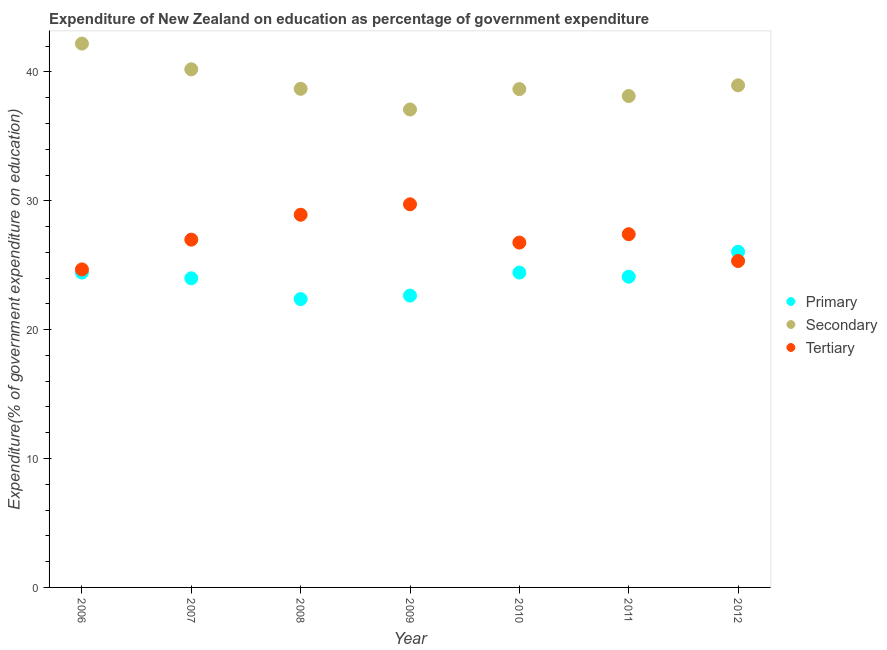What is the expenditure on secondary education in 2009?
Your answer should be very brief. 37.09. Across all years, what is the maximum expenditure on tertiary education?
Provide a short and direct response. 29.73. Across all years, what is the minimum expenditure on secondary education?
Your response must be concise. 37.09. In which year was the expenditure on secondary education minimum?
Your answer should be very brief. 2009. What is the total expenditure on tertiary education in the graph?
Your response must be concise. 189.8. What is the difference between the expenditure on secondary education in 2010 and that in 2011?
Offer a terse response. 0.54. What is the difference between the expenditure on tertiary education in 2011 and the expenditure on primary education in 2006?
Your answer should be very brief. 2.98. What is the average expenditure on secondary education per year?
Your answer should be very brief. 39.13. In the year 2012, what is the difference between the expenditure on tertiary education and expenditure on secondary education?
Keep it short and to the point. -13.63. What is the ratio of the expenditure on tertiary education in 2007 to that in 2010?
Make the answer very short. 1.01. Is the difference between the expenditure on secondary education in 2009 and 2010 greater than the difference between the expenditure on tertiary education in 2009 and 2010?
Make the answer very short. No. What is the difference between the highest and the second highest expenditure on secondary education?
Make the answer very short. 2. What is the difference between the highest and the lowest expenditure on secondary education?
Keep it short and to the point. 5.11. Is the sum of the expenditure on secondary education in 2007 and 2010 greater than the maximum expenditure on tertiary education across all years?
Provide a short and direct response. Yes. Does the expenditure on primary education monotonically increase over the years?
Offer a very short reply. No. Is the expenditure on primary education strictly greater than the expenditure on tertiary education over the years?
Offer a terse response. No. What is the difference between two consecutive major ticks on the Y-axis?
Your answer should be compact. 10. Does the graph contain any zero values?
Offer a terse response. No. Does the graph contain grids?
Provide a succinct answer. No. What is the title of the graph?
Keep it short and to the point. Expenditure of New Zealand on education as percentage of government expenditure. Does "Maunufacturing" appear as one of the legend labels in the graph?
Offer a very short reply. No. What is the label or title of the Y-axis?
Keep it short and to the point. Expenditure(% of government expenditure on education). What is the Expenditure(% of government expenditure on education) of Primary in 2006?
Your response must be concise. 24.43. What is the Expenditure(% of government expenditure on education) in Secondary in 2006?
Your response must be concise. 42.2. What is the Expenditure(% of government expenditure on education) in Tertiary in 2006?
Provide a short and direct response. 24.68. What is the Expenditure(% of government expenditure on education) in Primary in 2007?
Keep it short and to the point. 23.99. What is the Expenditure(% of government expenditure on education) of Secondary in 2007?
Make the answer very short. 40.2. What is the Expenditure(% of government expenditure on education) of Tertiary in 2007?
Give a very brief answer. 26.99. What is the Expenditure(% of government expenditure on education) in Primary in 2008?
Give a very brief answer. 22.37. What is the Expenditure(% of government expenditure on education) of Secondary in 2008?
Offer a very short reply. 38.69. What is the Expenditure(% of government expenditure on education) in Tertiary in 2008?
Make the answer very short. 28.92. What is the Expenditure(% of government expenditure on education) of Primary in 2009?
Your response must be concise. 22.65. What is the Expenditure(% of government expenditure on education) in Secondary in 2009?
Your response must be concise. 37.09. What is the Expenditure(% of government expenditure on education) of Tertiary in 2009?
Give a very brief answer. 29.73. What is the Expenditure(% of government expenditure on education) in Primary in 2010?
Provide a succinct answer. 24.43. What is the Expenditure(% of government expenditure on education) in Secondary in 2010?
Your response must be concise. 38.67. What is the Expenditure(% of government expenditure on education) in Tertiary in 2010?
Make the answer very short. 26.76. What is the Expenditure(% of government expenditure on education) in Primary in 2011?
Your response must be concise. 24.11. What is the Expenditure(% of government expenditure on education) in Secondary in 2011?
Make the answer very short. 38.13. What is the Expenditure(% of government expenditure on education) of Tertiary in 2011?
Offer a terse response. 27.41. What is the Expenditure(% of government expenditure on education) in Primary in 2012?
Provide a succinct answer. 26.05. What is the Expenditure(% of government expenditure on education) of Secondary in 2012?
Give a very brief answer. 38.96. What is the Expenditure(% of government expenditure on education) of Tertiary in 2012?
Provide a short and direct response. 25.33. Across all years, what is the maximum Expenditure(% of government expenditure on education) of Primary?
Make the answer very short. 26.05. Across all years, what is the maximum Expenditure(% of government expenditure on education) of Secondary?
Offer a terse response. 42.2. Across all years, what is the maximum Expenditure(% of government expenditure on education) in Tertiary?
Your answer should be very brief. 29.73. Across all years, what is the minimum Expenditure(% of government expenditure on education) of Primary?
Offer a very short reply. 22.37. Across all years, what is the minimum Expenditure(% of government expenditure on education) of Secondary?
Give a very brief answer. 37.09. Across all years, what is the minimum Expenditure(% of government expenditure on education) in Tertiary?
Ensure brevity in your answer.  24.68. What is the total Expenditure(% of government expenditure on education) in Primary in the graph?
Make the answer very short. 168.02. What is the total Expenditure(% of government expenditure on education) in Secondary in the graph?
Give a very brief answer. 273.93. What is the total Expenditure(% of government expenditure on education) in Tertiary in the graph?
Your answer should be compact. 189.8. What is the difference between the Expenditure(% of government expenditure on education) in Primary in 2006 and that in 2007?
Offer a terse response. 0.44. What is the difference between the Expenditure(% of government expenditure on education) of Secondary in 2006 and that in 2007?
Offer a very short reply. 2. What is the difference between the Expenditure(% of government expenditure on education) of Tertiary in 2006 and that in 2007?
Ensure brevity in your answer.  -2.31. What is the difference between the Expenditure(% of government expenditure on education) of Primary in 2006 and that in 2008?
Your response must be concise. 2.06. What is the difference between the Expenditure(% of government expenditure on education) of Secondary in 2006 and that in 2008?
Provide a succinct answer. 3.51. What is the difference between the Expenditure(% of government expenditure on education) in Tertiary in 2006 and that in 2008?
Ensure brevity in your answer.  -4.24. What is the difference between the Expenditure(% of government expenditure on education) in Primary in 2006 and that in 2009?
Make the answer very short. 1.78. What is the difference between the Expenditure(% of government expenditure on education) of Secondary in 2006 and that in 2009?
Your response must be concise. 5.11. What is the difference between the Expenditure(% of government expenditure on education) of Tertiary in 2006 and that in 2009?
Your answer should be compact. -5.05. What is the difference between the Expenditure(% of government expenditure on education) of Primary in 2006 and that in 2010?
Make the answer very short. -0. What is the difference between the Expenditure(% of government expenditure on education) in Secondary in 2006 and that in 2010?
Keep it short and to the point. 3.53. What is the difference between the Expenditure(% of government expenditure on education) in Tertiary in 2006 and that in 2010?
Provide a short and direct response. -2.08. What is the difference between the Expenditure(% of government expenditure on education) in Primary in 2006 and that in 2011?
Your answer should be very brief. 0.32. What is the difference between the Expenditure(% of government expenditure on education) of Secondary in 2006 and that in 2011?
Ensure brevity in your answer.  4.07. What is the difference between the Expenditure(% of government expenditure on education) of Tertiary in 2006 and that in 2011?
Ensure brevity in your answer.  -2.73. What is the difference between the Expenditure(% of government expenditure on education) in Primary in 2006 and that in 2012?
Your answer should be very brief. -1.62. What is the difference between the Expenditure(% of government expenditure on education) of Secondary in 2006 and that in 2012?
Ensure brevity in your answer.  3.24. What is the difference between the Expenditure(% of government expenditure on education) of Tertiary in 2006 and that in 2012?
Offer a terse response. -0.65. What is the difference between the Expenditure(% of government expenditure on education) in Primary in 2007 and that in 2008?
Your answer should be compact. 1.61. What is the difference between the Expenditure(% of government expenditure on education) of Secondary in 2007 and that in 2008?
Offer a terse response. 1.51. What is the difference between the Expenditure(% of government expenditure on education) of Tertiary in 2007 and that in 2008?
Your response must be concise. -1.93. What is the difference between the Expenditure(% of government expenditure on education) of Primary in 2007 and that in 2009?
Offer a terse response. 1.34. What is the difference between the Expenditure(% of government expenditure on education) of Secondary in 2007 and that in 2009?
Give a very brief answer. 3.12. What is the difference between the Expenditure(% of government expenditure on education) in Tertiary in 2007 and that in 2009?
Your response must be concise. -2.74. What is the difference between the Expenditure(% of government expenditure on education) of Primary in 2007 and that in 2010?
Keep it short and to the point. -0.44. What is the difference between the Expenditure(% of government expenditure on education) of Secondary in 2007 and that in 2010?
Provide a short and direct response. 1.53. What is the difference between the Expenditure(% of government expenditure on education) of Tertiary in 2007 and that in 2010?
Make the answer very short. 0.23. What is the difference between the Expenditure(% of government expenditure on education) in Primary in 2007 and that in 2011?
Your response must be concise. -0.12. What is the difference between the Expenditure(% of government expenditure on education) of Secondary in 2007 and that in 2011?
Your answer should be very brief. 2.07. What is the difference between the Expenditure(% of government expenditure on education) in Tertiary in 2007 and that in 2011?
Give a very brief answer. -0.42. What is the difference between the Expenditure(% of government expenditure on education) of Primary in 2007 and that in 2012?
Keep it short and to the point. -2.06. What is the difference between the Expenditure(% of government expenditure on education) of Secondary in 2007 and that in 2012?
Keep it short and to the point. 1.24. What is the difference between the Expenditure(% of government expenditure on education) of Tertiary in 2007 and that in 2012?
Offer a very short reply. 1.66. What is the difference between the Expenditure(% of government expenditure on education) in Primary in 2008 and that in 2009?
Keep it short and to the point. -0.27. What is the difference between the Expenditure(% of government expenditure on education) in Secondary in 2008 and that in 2009?
Ensure brevity in your answer.  1.6. What is the difference between the Expenditure(% of government expenditure on education) in Tertiary in 2008 and that in 2009?
Your answer should be very brief. -0.81. What is the difference between the Expenditure(% of government expenditure on education) in Primary in 2008 and that in 2010?
Make the answer very short. -2.06. What is the difference between the Expenditure(% of government expenditure on education) in Secondary in 2008 and that in 2010?
Your answer should be compact. 0.02. What is the difference between the Expenditure(% of government expenditure on education) of Tertiary in 2008 and that in 2010?
Offer a terse response. 2.16. What is the difference between the Expenditure(% of government expenditure on education) in Primary in 2008 and that in 2011?
Ensure brevity in your answer.  -1.74. What is the difference between the Expenditure(% of government expenditure on education) in Secondary in 2008 and that in 2011?
Provide a short and direct response. 0.56. What is the difference between the Expenditure(% of government expenditure on education) in Tertiary in 2008 and that in 2011?
Your answer should be compact. 1.51. What is the difference between the Expenditure(% of government expenditure on education) of Primary in 2008 and that in 2012?
Give a very brief answer. -3.68. What is the difference between the Expenditure(% of government expenditure on education) of Secondary in 2008 and that in 2012?
Keep it short and to the point. -0.27. What is the difference between the Expenditure(% of government expenditure on education) in Tertiary in 2008 and that in 2012?
Provide a short and direct response. 3.59. What is the difference between the Expenditure(% of government expenditure on education) in Primary in 2009 and that in 2010?
Offer a very short reply. -1.78. What is the difference between the Expenditure(% of government expenditure on education) of Secondary in 2009 and that in 2010?
Offer a very short reply. -1.58. What is the difference between the Expenditure(% of government expenditure on education) in Tertiary in 2009 and that in 2010?
Keep it short and to the point. 2.97. What is the difference between the Expenditure(% of government expenditure on education) in Primary in 2009 and that in 2011?
Your answer should be very brief. -1.46. What is the difference between the Expenditure(% of government expenditure on education) of Secondary in 2009 and that in 2011?
Offer a terse response. -1.04. What is the difference between the Expenditure(% of government expenditure on education) in Tertiary in 2009 and that in 2011?
Your response must be concise. 2.32. What is the difference between the Expenditure(% of government expenditure on education) in Primary in 2009 and that in 2012?
Offer a terse response. -3.4. What is the difference between the Expenditure(% of government expenditure on education) of Secondary in 2009 and that in 2012?
Offer a terse response. -1.87. What is the difference between the Expenditure(% of government expenditure on education) in Tertiary in 2009 and that in 2012?
Offer a terse response. 4.4. What is the difference between the Expenditure(% of government expenditure on education) in Primary in 2010 and that in 2011?
Give a very brief answer. 0.32. What is the difference between the Expenditure(% of government expenditure on education) in Secondary in 2010 and that in 2011?
Ensure brevity in your answer.  0.54. What is the difference between the Expenditure(% of government expenditure on education) in Tertiary in 2010 and that in 2011?
Keep it short and to the point. -0.65. What is the difference between the Expenditure(% of government expenditure on education) of Primary in 2010 and that in 2012?
Give a very brief answer. -1.62. What is the difference between the Expenditure(% of government expenditure on education) of Secondary in 2010 and that in 2012?
Your answer should be compact. -0.29. What is the difference between the Expenditure(% of government expenditure on education) in Tertiary in 2010 and that in 2012?
Make the answer very short. 1.43. What is the difference between the Expenditure(% of government expenditure on education) in Primary in 2011 and that in 2012?
Your response must be concise. -1.94. What is the difference between the Expenditure(% of government expenditure on education) in Secondary in 2011 and that in 2012?
Provide a succinct answer. -0.83. What is the difference between the Expenditure(% of government expenditure on education) of Tertiary in 2011 and that in 2012?
Offer a terse response. 2.08. What is the difference between the Expenditure(% of government expenditure on education) of Primary in 2006 and the Expenditure(% of government expenditure on education) of Secondary in 2007?
Ensure brevity in your answer.  -15.77. What is the difference between the Expenditure(% of government expenditure on education) of Primary in 2006 and the Expenditure(% of government expenditure on education) of Tertiary in 2007?
Ensure brevity in your answer.  -2.56. What is the difference between the Expenditure(% of government expenditure on education) in Secondary in 2006 and the Expenditure(% of government expenditure on education) in Tertiary in 2007?
Make the answer very short. 15.21. What is the difference between the Expenditure(% of government expenditure on education) in Primary in 2006 and the Expenditure(% of government expenditure on education) in Secondary in 2008?
Your answer should be compact. -14.26. What is the difference between the Expenditure(% of government expenditure on education) of Primary in 2006 and the Expenditure(% of government expenditure on education) of Tertiary in 2008?
Keep it short and to the point. -4.49. What is the difference between the Expenditure(% of government expenditure on education) of Secondary in 2006 and the Expenditure(% of government expenditure on education) of Tertiary in 2008?
Your response must be concise. 13.28. What is the difference between the Expenditure(% of government expenditure on education) in Primary in 2006 and the Expenditure(% of government expenditure on education) in Secondary in 2009?
Give a very brief answer. -12.66. What is the difference between the Expenditure(% of government expenditure on education) in Primary in 2006 and the Expenditure(% of government expenditure on education) in Tertiary in 2009?
Offer a terse response. -5.3. What is the difference between the Expenditure(% of government expenditure on education) of Secondary in 2006 and the Expenditure(% of government expenditure on education) of Tertiary in 2009?
Provide a succinct answer. 12.47. What is the difference between the Expenditure(% of government expenditure on education) of Primary in 2006 and the Expenditure(% of government expenditure on education) of Secondary in 2010?
Give a very brief answer. -14.24. What is the difference between the Expenditure(% of government expenditure on education) of Primary in 2006 and the Expenditure(% of government expenditure on education) of Tertiary in 2010?
Offer a very short reply. -2.33. What is the difference between the Expenditure(% of government expenditure on education) in Secondary in 2006 and the Expenditure(% of government expenditure on education) in Tertiary in 2010?
Your answer should be compact. 15.44. What is the difference between the Expenditure(% of government expenditure on education) of Primary in 2006 and the Expenditure(% of government expenditure on education) of Secondary in 2011?
Your answer should be compact. -13.7. What is the difference between the Expenditure(% of government expenditure on education) of Primary in 2006 and the Expenditure(% of government expenditure on education) of Tertiary in 2011?
Ensure brevity in your answer.  -2.98. What is the difference between the Expenditure(% of government expenditure on education) of Secondary in 2006 and the Expenditure(% of government expenditure on education) of Tertiary in 2011?
Your answer should be very brief. 14.79. What is the difference between the Expenditure(% of government expenditure on education) in Primary in 2006 and the Expenditure(% of government expenditure on education) in Secondary in 2012?
Offer a terse response. -14.53. What is the difference between the Expenditure(% of government expenditure on education) of Primary in 2006 and the Expenditure(% of government expenditure on education) of Tertiary in 2012?
Your response must be concise. -0.9. What is the difference between the Expenditure(% of government expenditure on education) in Secondary in 2006 and the Expenditure(% of government expenditure on education) in Tertiary in 2012?
Offer a very short reply. 16.87. What is the difference between the Expenditure(% of government expenditure on education) of Primary in 2007 and the Expenditure(% of government expenditure on education) of Secondary in 2008?
Your answer should be compact. -14.7. What is the difference between the Expenditure(% of government expenditure on education) of Primary in 2007 and the Expenditure(% of government expenditure on education) of Tertiary in 2008?
Keep it short and to the point. -4.93. What is the difference between the Expenditure(% of government expenditure on education) of Secondary in 2007 and the Expenditure(% of government expenditure on education) of Tertiary in 2008?
Offer a very short reply. 11.28. What is the difference between the Expenditure(% of government expenditure on education) of Primary in 2007 and the Expenditure(% of government expenditure on education) of Secondary in 2009?
Offer a very short reply. -13.1. What is the difference between the Expenditure(% of government expenditure on education) in Primary in 2007 and the Expenditure(% of government expenditure on education) in Tertiary in 2009?
Make the answer very short. -5.74. What is the difference between the Expenditure(% of government expenditure on education) of Secondary in 2007 and the Expenditure(% of government expenditure on education) of Tertiary in 2009?
Keep it short and to the point. 10.47. What is the difference between the Expenditure(% of government expenditure on education) in Primary in 2007 and the Expenditure(% of government expenditure on education) in Secondary in 2010?
Provide a short and direct response. -14.68. What is the difference between the Expenditure(% of government expenditure on education) of Primary in 2007 and the Expenditure(% of government expenditure on education) of Tertiary in 2010?
Your answer should be compact. -2.77. What is the difference between the Expenditure(% of government expenditure on education) of Secondary in 2007 and the Expenditure(% of government expenditure on education) of Tertiary in 2010?
Offer a terse response. 13.44. What is the difference between the Expenditure(% of government expenditure on education) of Primary in 2007 and the Expenditure(% of government expenditure on education) of Secondary in 2011?
Offer a very short reply. -14.14. What is the difference between the Expenditure(% of government expenditure on education) of Primary in 2007 and the Expenditure(% of government expenditure on education) of Tertiary in 2011?
Keep it short and to the point. -3.42. What is the difference between the Expenditure(% of government expenditure on education) of Secondary in 2007 and the Expenditure(% of government expenditure on education) of Tertiary in 2011?
Provide a short and direct response. 12.79. What is the difference between the Expenditure(% of government expenditure on education) of Primary in 2007 and the Expenditure(% of government expenditure on education) of Secondary in 2012?
Keep it short and to the point. -14.97. What is the difference between the Expenditure(% of government expenditure on education) of Primary in 2007 and the Expenditure(% of government expenditure on education) of Tertiary in 2012?
Provide a short and direct response. -1.34. What is the difference between the Expenditure(% of government expenditure on education) in Secondary in 2007 and the Expenditure(% of government expenditure on education) in Tertiary in 2012?
Your response must be concise. 14.87. What is the difference between the Expenditure(% of government expenditure on education) of Primary in 2008 and the Expenditure(% of government expenditure on education) of Secondary in 2009?
Keep it short and to the point. -14.71. What is the difference between the Expenditure(% of government expenditure on education) of Primary in 2008 and the Expenditure(% of government expenditure on education) of Tertiary in 2009?
Your answer should be very brief. -7.35. What is the difference between the Expenditure(% of government expenditure on education) of Secondary in 2008 and the Expenditure(% of government expenditure on education) of Tertiary in 2009?
Your answer should be very brief. 8.96. What is the difference between the Expenditure(% of government expenditure on education) in Primary in 2008 and the Expenditure(% of government expenditure on education) in Secondary in 2010?
Offer a terse response. -16.3. What is the difference between the Expenditure(% of government expenditure on education) of Primary in 2008 and the Expenditure(% of government expenditure on education) of Tertiary in 2010?
Make the answer very short. -4.38. What is the difference between the Expenditure(% of government expenditure on education) in Secondary in 2008 and the Expenditure(% of government expenditure on education) in Tertiary in 2010?
Provide a succinct answer. 11.93. What is the difference between the Expenditure(% of government expenditure on education) of Primary in 2008 and the Expenditure(% of government expenditure on education) of Secondary in 2011?
Provide a short and direct response. -15.76. What is the difference between the Expenditure(% of government expenditure on education) of Primary in 2008 and the Expenditure(% of government expenditure on education) of Tertiary in 2011?
Your answer should be very brief. -5.04. What is the difference between the Expenditure(% of government expenditure on education) in Secondary in 2008 and the Expenditure(% of government expenditure on education) in Tertiary in 2011?
Ensure brevity in your answer.  11.28. What is the difference between the Expenditure(% of government expenditure on education) in Primary in 2008 and the Expenditure(% of government expenditure on education) in Secondary in 2012?
Your answer should be compact. -16.59. What is the difference between the Expenditure(% of government expenditure on education) of Primary in 2008 and the Expenditure(% of government expenditure on education) of Tertiary in 2012?
Make the answer very short. -2.96. What is the difference between the Expenditure(% of government expenditure on education) in Secondary in 2008 and the Expenditure(% of government expenditure on education) in Tertiary in 2012?
Offer a terse response. 13.36. What is the difference between the Expenditure(% of government expenditure on education) in Primary in 2009 and the Expenditure(% of government expenditure on education) in Secondary in 2010?
Your answer should be very brief. -16.02. What is the difference between the Expenditure(% of government expenditure on education) of Primary in 2009 and the Expenditure(% of government expenditure on education) of Tertiary in 2010?
Provide a succinct answer. -4.11. What is the difference between the Expenditure(% of government expenditure on education) of Secondary in 2009 and the Expenditure(% of government expenditure on education) of Tertiary in 2010?
Offer a very short reply. 10.33. What is the difference between the Expenditure(% of government expenditure on education) in Primary in 2009 and the Expenditure(% of government expenditure on education) in Secondary in 2011?
Your answer should be very brief. -15.48. What is the difference between the Expenditure(% of government expenditure on education) in Primary in 2009 and the Expenditure(% of government expenditure on education) in Tertiary in 2011?
Make the answer very short. -4.76. What is the difference between the Expenditure(% of government expenditure on education) in Secondary in 2009 and the Expenditure(% of government expenditure on education) in Tertiary in 2011?
Give a very brief answer. 9.68. What is the difference between the Expenditure(% of government expenditure on education) in Primary in 2009 and the Expenditure(% of government expenditure on education) in Secondary in 2012?
Ensure brevity in your answer.  -16.31. What is the difference between the Expenditure(% of government expenditure on education) in Primary in 2009 and the Expenditure(% of government expenditure on education) in Tertiary in 2012?
Provide a succinct answer. -2.68. What is the difference between the Expenditure(% of government expenditure on education) in Secondary in 2009 and the Expenditure(% of government expenditure on education) in Tertiary in 2012?
Your answer should be very brief. 11.76. What is the difference between the Expenditure(% of government expenditure on education) in Primary in 2010 and the Expenditure(% of government expenditure on education) in Secondary in 2011?
Offer a terse response. -13.7. What is the difference between the Expenditure(% of government expenditure on education) of Primary in 2010 and the Expenditure(% of government expenditure on education) of Tertiary in 2011?
Make the answer very short. -2.98. What is the difference between the Expenditure(% of government expenditure on education) of Secondary in 2010 and the Expenditure(% of government expenditure on education) of Tertiary in 2011?
Provide a short and direct response. 11.26. What is the difference between the Expenditure(% of government expenditure on education) in Primary in 2010 and the Expenditure(% of government expenditure on education) in Secondary in 2012?
Your response must be concise. -14.53. What is the difference between the Expenditure(% of government expenditure on education) in Primary in 2010 and the Expenditure(% of government expenditure on education) in Tertiary in 2012?
Offer a very short reply. -0.9. What is the difference between the Expenditure(% of government expenditure on education) of Secondary in 2010 and the Expenditure(% of government expenditure on education) of Tertiary in 2012?
Provide a short and direct response. 13.34. What is the difference between the Expenditure(% of government expenditure on education) of Primary in 2011 and the Expenditure(% of government expenditure on education) of Secondary in 2012?
Offer a very short reply. -14.85. What is the difference between the Expenditure(% of government expenditure on education) of Primary in 2011 and the Expenditure(% of government expenditure on education) of Tertiary in 2012?
Keep it short and to the point. -1.22. What is the difference between the Expenditure(% of government expenditure on education) in Secondary in 2011 and the Expenditure(% of government expenditure on education) in Tertiary in 2012?
Keep it short and to the point. 12.8. What is the average Expenditure(% of government expenditure on education) of Primary per year?
Offer a terse response. 24. What is the average Expenditure(% of government expenditure on education) in Secondary per year?
Your answer should be compact. 39.13. What is the average Expenditure(% of government expenditure on education) of Tertiary per year?
Ensure brevity in your answer.  27.11. In the year 2006, what is the difference between the Expenditure(% of government expenditure on education) in Primary and Expenditure(% of government expenditure on education) in Secondary?
Ensure brevity in your answer.  -17.77. In the year 2006, what is the difference between the Expenditure(% of government expenditure on education) in Primary and Expenditure(% of government expenditure on education) in Tertiary?
Offer a terse response. -0.25. In the year 2006, what is the difference between the Expenditure(% of government expenditure on education) in Secondary and Expenditure(% of government expenditure on education) in Tertiary?
Offer a very short reply. 17.52. In the year 2007, what is the difference between the Expenditure(% of government expenditure on education) of Primary and Expenditure(% of government expenditure on education) of Secondary?
Make the answer very short. -16.22. In the year 2007, what is the difference between the Expenditure(% of government expenditure on education) in Primary and Expenditure(% of government expenditure on education) in Tertiary?
Your answer should be compact. -3. In the year 2007, what is the difference between the Expenditure(% of government expenditure on education) in Secondary and Expenditure(% of government expenditure on education) in Tertiary?
Your answer should be compact. 13.22. In the year 2008, what is the difference between the Expenditure(% of government expenditure on education) of Primary and Expenditure(% of government expenditure on education) of Secondary?
Your answer should be compact. -16.32. In the year 2008, what is the difference between the Expenditure(% of government expenditure on education) in Primary and Expenditure(% of government expenditure on education) in Tertiary?
Your answer should be compact. -6.54. In the year 2008, what is the difference between the Expenditure(% of government expenditure on education) of Secondary and Expenditure(% of government expenditure on education) of Tertiary?
Make the answer very short. 9.77. In the year 2009, what is the difference between the Expenditure(% of government expenditure on education) of Primary and Expenditure(% of government expenditure on education) of Secondary?
Your answer should be very brief. -14.44. In the year 2009, what is the difference between the Expenditure(% of government expenditure on education) of Primary and Expenditure(% of government expenditure on education) of Tertiary?
Your answer should be compact. -7.08. In the year 2009, what is the difference between the Expenditure(% of government expenditure on education) in Secondary and Expenditure(% of government expenditure on education) in Tertiary?
Your response must be concise. 7.36. In the year 2010, what is the difference between the Expenditure(% of government expenditure on education) of Primary and Expenditure(% of government expenditure on education) of Secondary?
Offer a very short reply. -14.24. In the year 2010, what is the difference between the Expenditure(% of government expenditure on education) in Primary and Expenditure(% of government expenditure on education) in Tertiary?
Give a very brief answer. -2.33. In the year 2010, what is the difference between the Expenditure(% of government expenditure on education) of Secondary and Expenditure(% of government expenditure on education) of Tertiary?
Offer a very short reply. 11.91. In the year 2011, what is the difference between the Expenditure(% of government expenditure on education) of Primary and Expenditure(% of government expenditure on education) of Secondary?
Provide a short and direct response. -14.02. In the year 2011, what is the difference between the Expenditure(% of government expenditure on education) in Primary and Expenditure(% of government expenditure on education) in Tertiary?
Keep it short and to the point. -3.3. In the year 2011, what is the difference between the Expenditure(% of government expenditure on education) of Secondary and Expenditure(% of government expenditure on education) of Tertiary?
Give a very brief answer. 10.72. In the year 2012, what is the difference between the Expenditure(% of government expenditure on education) in Primary and Expenditure(% of government expenditure on education) in Secondary?
Provide a succinct answer. -12.91. In the year 2012, what is the difference between the Expenditure(% of government expenditure on education) in Primary and Expenditure(% of government expenditure on education) in Tertiary?
Keep it short and to the point. 0.72. In the year 2012, what is the difference between the Expenditure(% of government expenditure on education) of Secondary and Expenditure(% of government expenditure on education) of Tertiary?
Provide a succinct answer. 13.63. What is the ratio of the Expenditure(% of government expenditure on education) of Primary in 2006 to that in 2007?
Provide a succinct answer. 1.02. What is the ratio of the Expenditure(% of government expenditure on education) in Secondary in 2006 to that in 2007?
Provide a short and direct response. 1.05. What is the ratio of the Expenditure(% of government expenditure on education) of Tertiary in 2006 to that in 2007?
Your answer should be very brief. 0.91. What is the ratio of the Expenditure(% of government expenditure on education) of Primary in 2006 to that in 2008?
Your answer should be compact. 1.09. What is the ratio of the Expenditure(% of government expenditure on education) in Secondary in 2006 to that in 2008?
Your answer should be very brief. 1.09. What is the ratio of the Expenditure(% of government expenditure on education) of Tertiary in 2006 to that in 2008?
Your answer should be compact. 0.85. What is the ratio of the Expenditure(% of government expenditure on education) of Primary in 2006 to that in 2009?
Your answer should be very brief. 1.08. What is the ratio of the Expenditure(% of government expenditure on education) in Secondary in 2006 to that in 2009?
Offer a terse response. 1.14. What is the ratio of the Expenditure(% of government expenditure on education) of Tertiary in 2006 to that in 2009?
Offer a very short reply. 0.83. What is the ratio of the Expenditure(% of government expenditure on education) of Secondary in 2006 to that in 2010?
Provide a short and direct response. 1.09. What is the ratio of the Expenditure(% of government expenditure on education) of Tertiary in 2006 to that in 2010?
Keep it short and to the point. 0.92. What is the ratio of the Expenditure(% of government expenditure on education) in Primary in 2006 to that in 2011?
Keep it short and to the point. 1.01. What is the ratio of the Expenditure(% of government expenditure on education) in Secondary in 2006 to that in 2011?
Make the answer very short. 1.11. What is the ratio of the Expenditure(% of government expenditure on education) in Tertiary in 2006 to that in 2011?
Offer a very short reply. 0.9. What is the ratio of the Expenditure(% of government expenditure on education) of Primary in 2006 to that in 2012?
Ensure brevity in your answer.  0.94. What is the ratio of the Expenditure(% of government expenditure on education) of Secondary in 2006 to that in 2012?
Offer a terse response. 1.08. What is the ratio of the Expenditure(% of government expenditure on education) in Tertiary in 2006 to that in 2012?
Make the answer very short. 0.97. What is the ratio of the Expenditure(% of government expenditure on education) in Primary in 2007 to that in 2008?
Your answer should be compact. 1.07. What is the ratio of the Expenditure(% of government expenditure on education) in Secondary in 2007 to that in 2008?
Make the answer very short. 1.04. What is the ratio of the Expenditure(% of government expenditure on education) in Tertiary in 2007 to that in 2008?
Offer a terse response. 0.93. What is the ratio of the Expenditure(% of government expenditure on education) in Primary in 2007 to that in 2009?
Provide a succinct answer. 1.06. What is the ratio of the Expenditure(% of government expenditure on education) in Secondary in 2007 to that in 2009?
Your response must be concise. 1.08. What is the ratio of the Expenditure(% of government expenditure on education) in Tertiary in 2007 to that in 2009?
Provide a succinct answer. 0.91. What is the ratio of the Expenditure(% of government expenditure on education) of Primary in 2007 to that in 2010?
Offer a terse response. 0.98. What is the ratio of the Expenditure(% of government expenditure on education) of Secondary in 2007 to that in 2010?
Keep it short and to the point. 1.04. What is the ratio of the Expenditure(% of government expenditure on education) in Tertiary in 2007 to that in 2010?
Offer a very short reply. 1.01. What is the ratio of the Expenditure(% of government expenditure on education) of Primary in 2007 to that in 2011?
Your answer should be compact. 0.99. What is the ratio of the Expenditure(% of government expenditure on education) of Secondary in 2007 to that in 2011?
Offer a very short reply. 1.05. What is the ratio of the Expenditure(% of government expenditure on education) of Tertiary in 2007 to that in 2011?
Provide a short and direct response. 0.98. What is the ratio of the Expenditure(% of government expenditure on education) in Primary in 2007 to that in 2012?
Make the answer very short. 0.92. What is the ratio of the Expenditure(% of government expenditure on education) in Secondary in 2007 to that in 2012?
Keep it short and to the point. 1.03. What is the ratio of the Expenditure(% of government expenditure on education) in Tertiary in 2007 to that in 2012?
Provide a succinct answer. 1.07. What is the ratio of the Expenditure(% of government expenditure on education) of Primary in 2008 to that in 2009?
Provide a short and direct response. 0.99. What is the ratio of the Expenditure(% of government expenditure on education) of Secondary in 2008 to that in 2009?
Your answer should be very brief. 1.04. What is the ratio of the Expenditure(% of government expenditure on education) of Tertiary in 2008 to that in 2009?
Make the answer very short. 0.97. What is the ratio of the Expenditure(% of government expenditure on education) in Primary in 2008 to that in 2010?
Make the answer very short. 0.92. What is the ratio of the Expenditure(% of government expenditure on education) in Secondary in 2008 to that in 2010?
Give a very brief answer. 1. What is the ratio of the Expenditure(% of government expenditure on education) in Tertiary in 2008 to that in 2010?
Keep it short and to the point. 1.08. What is the ratio of the Expenditure(% of government expenditure on education) in Primary in 2008 to that in 2011?
Keep it short and to the point. 0.93. What is the ratio of the Expenditure(% of government expenditure on education) of Secondary in 2008 to that in 2011?
Offer a very short reply. 1.01. What is the ratio of the Expenditure(% of government expenditure on education) of Tertiary in 2008 to that in 2011?
Offer a very short reply. 1.06. What is the ratio of the Expenditure(% of government expenditure on education) of Primary in 2008 to that in 2012?
Make the answer very short. 0.86. What is the ratio of the Expenditure(% of government expenditure on education) in Secondary in 2008 to that in 2012?
Make the answer very short. 0.99. What is the ratio of the Expenditure(% of government expenditure on education) of Tertiary in 2008 to that in 2012?
Your answer should be compact. 1.14. What is the ratio of the Expenditure(% of government expenditure on education) in Primary in 2009 to that in 2010?
Offer a terse response. 0.93. What is the ratio of the Expenditure(% of government expenditure on education) in Secondary in 2009 to that in 2010?
Your response must be concise. 0.96. What is the ratio of the Expenditure(% of government expenditure on education) in Tertiary in 2009 to that in 2010?
Offer a terse response. 1.11. What is the ratio of the Expenditure(% of government expenditure on education) in Primary in 2009 to that in 2011?
Your response must be concise. 0.94. What is the ratio of the Expenditure(% of government expenditure on education) in Secondary in 2009 to that in 2011?
Your response must be concise. 0.97. What is the ratio of the Expenditure(% of government expenditure on education) of Tertiary in 2009 to that in 2011?
Give a very brief answer. 1.08. What is the ratio of the Expenditure(% of government expenditure on education) of Primary in 2009 to that in 2012?
Provide a succinct answer. 0.87. What is the ratio of the Expenditure(% of government expenditure on education) of Secondary in 2009 to that in 2012?
Provide a short and direct response. 0.95. What is the ratio of the Expenditure(% of government expenditure on education) in Tertiary in 2009 to that in 2012?
Give a very brief answer. 1.17. What is the ratio of the Expenditure(% of government expenditure on education) in Primary in 2010 to that in 2011?
Ensure brevity in your answer.  1.01. What is the ratio of the Expenditure(% of government expenditure on education) in Secondary in 2010 to that in 2011?
Give a very brief answer. 1.01. What is the ratio of the Expenditure(% of government expenditure on education) of Tertiary in 2010 to that in 2011?
Provide a short and direct response. 0.98. What is the ratio of the Expenditure(% of government expenditure on education) in Primary in 2010 to that in 2012?
Give a very brief answer. 0.94. What is the ratio of the Expenditure(% of government expenditure on education) of Secondary in 2010 to that in 2012?
Provide a short and direct response. 0.99. What is the ratio of the Expenditure(% of government expenditure on education) of Tertiary in 2010 to that in 2012?
Give a very brief answer. 1.06. What is the ratio of the Expenditure(% of government expenditure on education) of Primary in 2011 to that in 2012?
Ensure brevity in your answer.  0.93. What is the ratio of the Expenditure(% of government expenditure on education) in Secondary in 2011 to that in 2012?
Your response must be concise. 0.98. What is the ratio of the Expenditure(% of government expenditure on education) of Tertiary in 2011 to that in 2012?
Give a very brief answer. 1.08. What is the difference between the highest and the second highest Expenditure(% of government expenditure on education) of Primary?
Your answer should be very brief. 1.62. What is the difference between the highest and the second highest Expenditure(% of government expenditure on education) of Secondary?
Offer a terse response. 2. What is the difference between the highest and the second highest Expenditure(% of government expenditure on education) in Tertiary?
Provide a succinct answer. 0.81. What is the difference between the highest and the lowest Expenditure(% of government expenditure on education) of Primary?
Offer a very short reply. 3.68. What is the difference between the highest and the lowest Expenditure(% of government expenditure on education) of Secondary?
Offer a terse response. 5.11. What is the difference between the highest and the lowest Expenditure(% of government expenditure on education) in Tertiary?
Your answer should be compact. 5.05. 